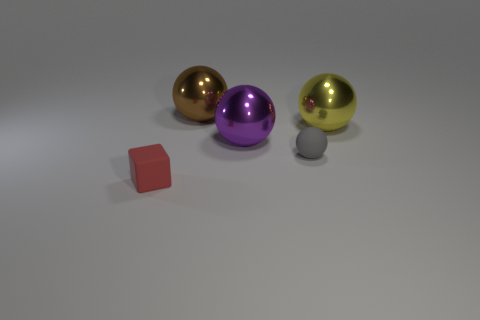What is the material of the big purple object?
Your response must be concise. Metal. What number of spheres are either yellow things or gray matte objects?
Give a very brief answer. 2. The big object right of the rubber ball is what color?
Your answer should be very brief. Yellow. How many other blocks have the same size as the block?
Ensure brevity in your answer.  0. There is a big object that is to the right of the gray matte ball; is its shape the same as the tiny rubber object that is left of the rubber ball?
Make the answer very short. No. There is a big purple ball right of the object in front of the tiny rubber object that is right of the tiny red cube; what is its material?
Make the answer very short. Metal. What shape is the object that is the same size as the gray ball?
Your response must be concise. Cube. Is there a big thing that has the same color as the small ball?
Ensure brevity in your answer.  No. The purple object has what size?
Your answer should be compact. Large. Do the big yellow ball and the brown sphere have the same material?
Give a very brief answer. Yes. 